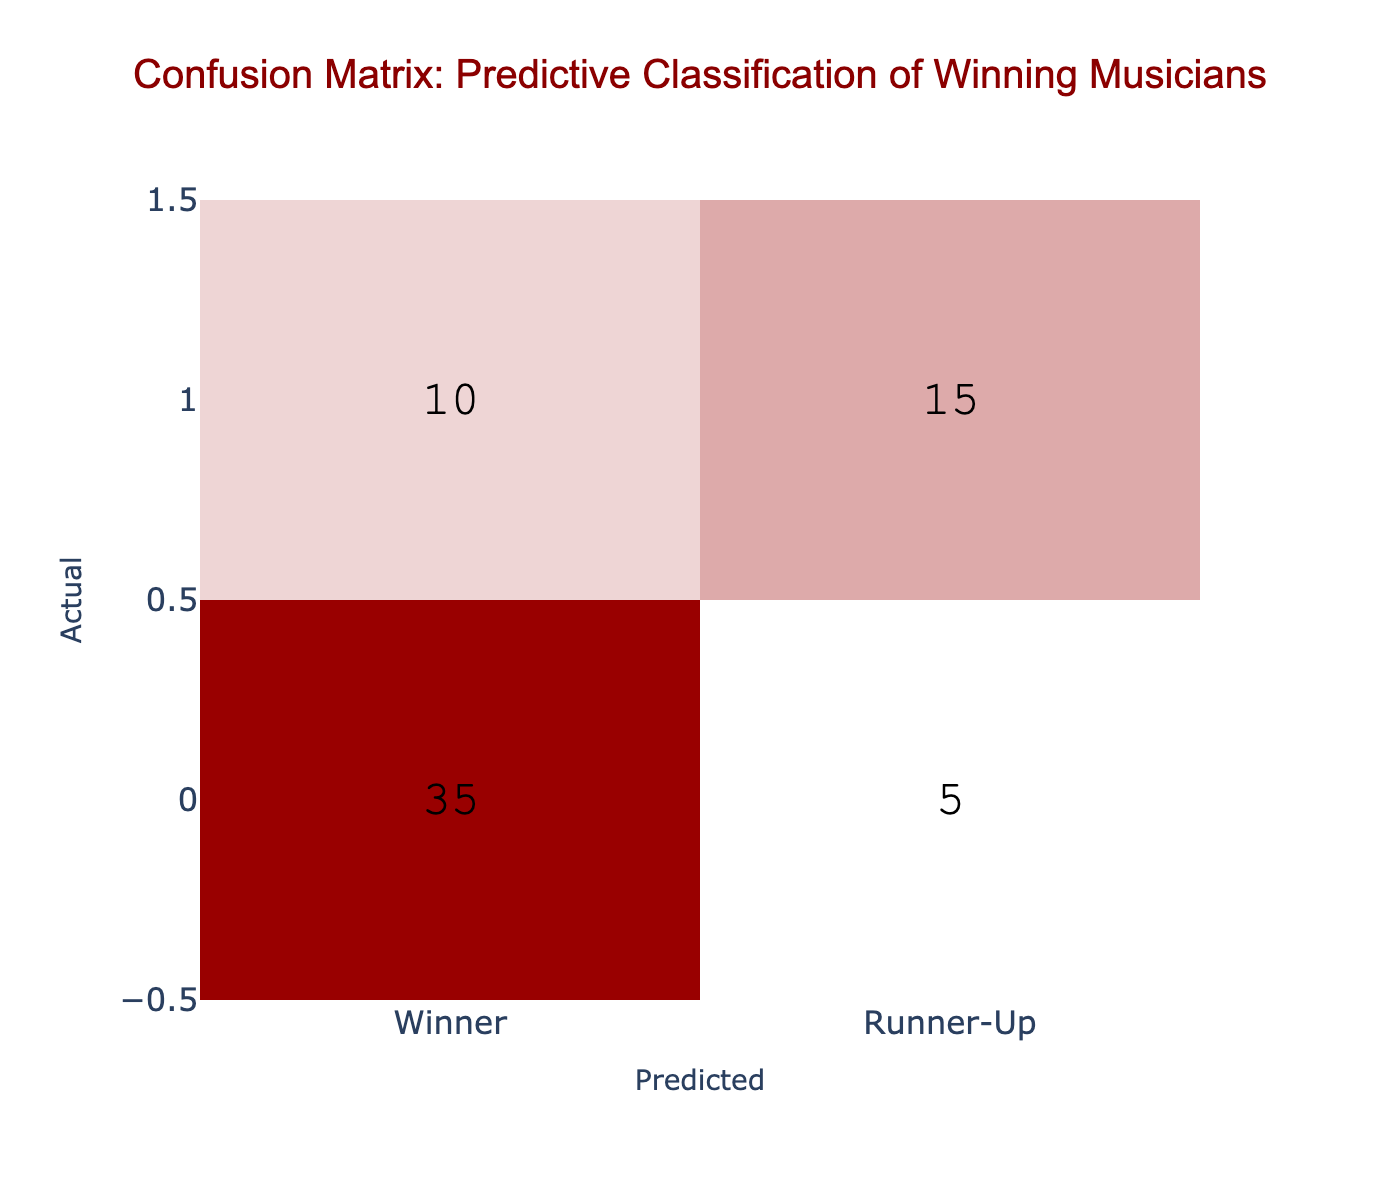What is the total number of winners predicted? To find the total number of winners predicted, we add up the values in the "Winner" column under the predicted classifications: 35 (true winners) + 10 (predicted winners who actually turned out to be runner-ups) = 45.
Answer: 45 How many actual runner-ups were incorrectly predicted as winners? The number of actual runner-ups predicted as winners can be found in the table where "Runner-Up" is the actual category and "Winner" is the predicted category, which is 10.
Answer: 10 What is the number of actual winners predicted correctly? The number of actual winners predicted correctly is located at the position of "Winner" under the "Winner" predicted classification, which is 35.
Answer: 35 What is the accuracy of the predictions? Accuracy is calculated using the formula (True Positives + True Negatives) / Total Observations. Here, True Positives = 35 and True Negatives = 15, with Total = 35 + 5 + 10 + 15 = 65. Therefore, accuracy = (35 + 15) / 65 = 50 / 65 = approximately 0.7692 or 76.92%.
Answer: 76.92% Is there a higher number of true winners or true runner-ups predicted? To answer this, we look at the values in the table: true winners (35) and true runner-ups (15). Since 35 is greater than 15, the answer is true winners.
Answer: Yes, true winners How many predicted runner-ups turned out to be true winners? This can be directly observed from the table in the "Winner" row under the "Runner-Up" predicted classification, which is 5.
Answer: 5 What percentage of actual winners were correctly identified? This percentage can be calculated by taking the true winners (35) and dividing it by the total actual winners, which is 35 + 10 = 45. Thus, the percentage = (35 / 45) * 100 = 77.78%.
Answer: 77.78% 